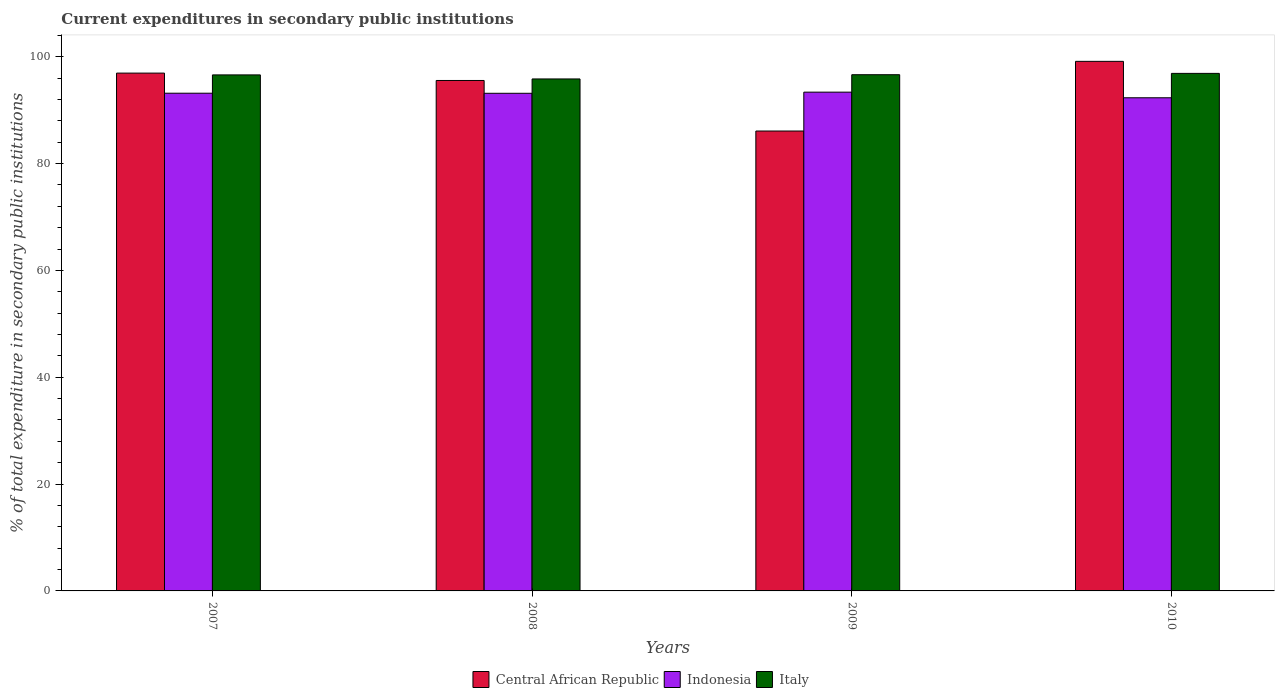How many different coloured bars are there?
Your response must be concise. 3. Are the number of bars per tick equal to the number of legend labels?
Offer a very short reply. Yes. How many bars are there on the 1st tick from the left?
Your answer should be compact. 3. How many bars are there on the 1st tick from the right?
Offer a terse response. 3. In how many cases, is the number of bars for a given year not equal to the number of legend labels?
Give a very brief answer. 0. What is the current expenditures in secondary public institutions in Central African Republic in 2009?
Your response must be concise. 86.08. Across all years, what is the maximum current expenditures in secondary public institutions in Italy?
Your answer should be very brief. 96.87. Across all years, what is the minimum current expenditures in secondary public institutions in Italy?
Make the answer very short. 95.83. In which year was the current expenditures in secondary public institutions in Indonesia maximum?
Your response must be concise. 2009. In which year was the current expenditures in secondary public institutions in Central African Republic minimum?
Your response must be concise. 2009. What is the total current expenditures in secondary public institutions in Central African Republic in the graph?
Offer a very short reply. 377.68. What is the difference between the current expenditures in secondary public institutions in Central African Republic in 2007 and that in 2009?
Ensure brevity in your answer.  10.84. What is the difference between the current expenditures in secondary public institutions in Indonesia in 2008 and the current expenditures in secondary public institutions in Central African Republic in 2010?
Your answer should be very brief. -5.98. What is the average current expenditures in secondary public institutions in Central African Republic per year?
Make the answer very short. 94.42. In the year 2010, what is the difference between the current expenditures in secondary public institutions in Central African Republic and current expenditures in secondary public institutions in Italy?
Keep it short and to the point. 2.25. In how many years, is the current expenditures in secondary public institutions in Central African Republic greater than 52 %?
Give a very brief answer. 4. What is the ratio of the current expenditures in secondary public institutions in Indonesia in 2008 to that in 2010?
Ensure brevity in your answer.  1.01. What is the difference between the highest and the second highest current expenditures in secondary public institutions in Indonesia?
Ensure brevity in your answer.  0.2. What is the difference between the highest and the lowest current expenditures in secondary public institutions in Italy?
Keep it short and to the point. 1.04. What does the 1st bar from the left in 2009 represents?
Give a very brief answer. Central African Republic. How many bars are there?
Offer a very short reply. 12. Are the values on the major ticks of Y-axis written in scientific E-notation?
Your answer should be very brief. No. Does the graph contain any zero values?
Keep it short and to the point. No. Where does the legend appear in the graph?
Offer a very short reply. Bottom center. How many legend labels are there?
Ensure brevity in your answer.  3. How are the legend labels stacked?
Provide a short and direct response. Horizontal. What is the title of the graph?
Ensure brevity in your answer.  Current expenditures in secondary public institutions. What is the label or title of the X-axis?
Make the answer very short. Years. What is the label or title of the Y-axis?
Offer a very short reply. % of total expenditure in secondary public institutions. What is the % of total expenditure in secondary public institutions in Central African Republic in 2007?
Ensure brevity in your answer.  96.92. What is the % of total expenditure in secondary public institutions of Indonesia in 2007?
Ensure brevity in your answer.  93.16. What is the % of total expenditure in secondary public institutions in Italy in 2007?
Offer a terse response. 96.59. What is the % of total expenditure in secondary public institutions of Central African Republic in 2008?
Provide a succinct answer. 95.54. What is the % of total expenditure in secondary public institutions in Indonesia in 2008?
Make the answer very short. 93.15. What is the % of total expenditure in secondary public institutions in Italy in 2008?
Offer a terse response. 95.83. What is the % of total expenditure in secondary public institutions in Central African Republic in 2009?
Ensure brevity in your answer.  86.08. What is the % of total expenditure in secondary public institutions of Indonesia in 2009?
Provide a short and direct response. 93.36. What is the % of total expenditure in secondary public institutions of Italy in 2009?
Provide a short and direct response. 96.62. What is the % of total expenditure in secondary public institutions of Central African Republic in 2010?
Your answer should be very brief. 99.12. What is the % of total expenditure in secondary public institutions of Indonesia in 2010?
Give a very brief answer. 92.31. What is the % of total expenditure in secondary public institutions in Italy in 2010?
Provide a short and direct response. 96.87. Across all years, what is the maximum % of total expenditure in secondary public institutions of Central African Republic?
Make the answer very short. 99.12. Across all years, what is the maximum % of total expenditure in secondary public institutions in Indonesia?
Offer a terse response. 93.36. Across all years, what is the maximum % of total expenditure in secondary public institutions in Italy?
Your answer should be very brief. 96.87. Across all years, what is the minimum % of total expenditure in secondary public institutions of Central African Republic?
Provide a short and direct response. 86.08. Across all years, what is the minimum % of total expenditure in secondary public institutions in Indonesia?
Offer a terse response. 92.31. Across all years, what is the minimum % of total expenditure in secondary public institutions of Italy?
Provide a short and direct response. 95.83. What is the total % of total expenditure in secondary public institutions in Central African Republic in the graph?
Provide a short and direct response. 377.68. What is the total % of total expenditure in secondary public institutions in Indonesia in the graph?
Provide a succinct answer. 371.97. What is the total % of total expenditure in secondary public institutions in Italy in the graph?
Offer a very short reply. 385.92. What is the difference between the % of total expenditure in secondary public institutions in Central African Republic in 2007 and that in 2008?
Your response must be concise. 1.38. What is the difference between the % of total expenditure in secondary public institutions in Indonesia in 2007 and that in 2008?
Your answer should be compact. 0.02. What is the difference between the % of total expenditure in secondary public institutions in Italy in 2007 and that in 2008?
Your answer should be very brief. 0.76. What is the difference between the % of total expenditure in secondary public institutions in Central African Republic in 2007 and that in 2009?
Offer a terse response. 10.84. What is the difference between the % of total expenditure in secondary public institutions of Indonesia in 2007 and that in 2009?
Provide a short and direct response. -0.2. What is the difference between the % of total expenditure in secondary public institutions of Italy in 2007 and that in 2009?
Provide a short and direct response. -0.03. What is the difference between the % of total expenditure in secondary public institutions of Indonesia in 2007 and that in 2010?
Give a very brief answer. 0.85. What is the difference between the % of total expenditure in secondary public institutions in Italy in 2007 and that in 2010?
Your answer should be very brief. -0.28. What is the difference between the % of total expenditure in secondary public institutions in Central African Republic in 2008 and that in 2009?
Your answer should be compact. 9.46. What is the difference between the % of total expenditure in secondary public institutions of Indonesia in 2008 and that in 2009?
Offer a terse response. -0.21. What is the difference between the % of total expenditure in secondary public institutions of Italy in 2008 and that in 2009?
Your answer should be compact. -0.79. What is the difference between the % of total expenditure in secondary public institutions of Central African Republic in 2008 and that in 2010?
Offer a very short reply. -3.58. What is the difference between the % of total expenditure in secondary public institutions in Indonesia in 2008 and that in 2010?
Offer a very short reply. 0.84. What is the difference between the % of total expenditure in secondary public institutions in Italy in 2008 and that in 2010?
Keep it short and to the point. -1.04. What is the difference between the % of total expenditure in secondary public institutions of Central African Republic in 2009 and that in 2010?
Make the answer very short. -13.04. What is the difference between the % of total expenditure in secondary public institutions of Indonesia in 2009 and that in 2010?
Your response must be concise. 1.05. What is the difference between the % of total expenditure in secondary public institutions in Italy in 2009 and that in 2010?
Offer a very short reply. -0.25. What is the difference between the % of total expenditure in secondary public institutions of Central African Republic in 2007 and the % of total expenditure in secondary public institutions of Indonesia in 2008?
Ensure brevity in your answer.  3.78. What is the difference between the % of total expenditure in secondary public institutions in Central African Republic in 2007 and the % of total expenditure in secondary public institutions in Italy in 2008?
Keep it short and to the point. 1.09. What is the difference between the % of total expenditure in secondary public institutions in Indonesia in 2007 and the % of total expenditure in secondary public institutions in Italy in 2008?
Give a very brief answer. -2.67. What is the difference between the % of total expenditure in secondary public institutions in Central African Republic in 2007 and the % of total expenditure in secondary public institutions in Indonesia in 2009?
Offer a very short reply. 3.56. What is the difference between the % of total expenditure in secondary public institutions of Central African Republic in 2007 and the % of total expenditure in secondary public institutions of Italy in 2009?
Ensure brevity in your answer.  0.3. What is the difference between the % of total expenditure in secondary public institutions in Indonesia in 2007 and the % of total expenditure in secondary public institutions in Italy in 2009?
Offer a terse response. -3.46. What is the difference between the % of total expenditure in secondary public institutions of Central African Republic in 2007 and the % of total expenditure in secondary public institutions of Indonesia in 2010?
Give a very brief answer. 4.62. What is the difference between the % of total expenditure in secondary public institutions of Central African Republic in 2007 and the % of total expenditure in secondary public institutions of Italy in 2010?
Provide a succinct answer. 0.05. What is the difference between the % of total expenditure in secondary public institutions in Indonesia in 2007 and the % of total expenditure in secondary public institutions in Italy in 2010?
Make the answer very short. -3.71. What is the difference between the % of total expenditure in secondary public institutions of Central African Republic in 2008 and the % of total expenditure in secondary public institutions of Indonesia in 2009?
Keep it short and to the point. 2.19. What is the difference between the % of total expenditure in secondary public institutions in Central African Republic in 2008 and the % of total expenditure in secondary public institutions in Italy in 2009?
Provide a succinct answer. -1.08. What is the difference between the % of total expenditure in secondary public institutions of Indonesia in 2008 and the % of total expenditure in secondary public institutions of Italy in 2009?
Your answer should be very brief. -3.48. What is the difference between the % of total expenditure in secondary public institutions in Central African Republic in 2008 and the % of total expenditure in secondary public institutions in Indonesia in 2010?
Keep it short and to the point. 3.24. What is the difference between the % of total expenditure in secondary public institutions in Central African Republic in 2008 and the % of total expenditure in secondary public institutions in Italy in 2010?
Offer a terse response. -1.33. What is the difference between the % of total expenditure in secondary public institutions of Indonesia in 2008 and the % of total expenditure in secondary public institutions of Italy in 2010?
Provide a succinct answer. -3.73. What is the difference between the % of total expenditure in secondary public institutions of Central African Republic in 2009 and the % of total expenditure in secondary public institutions of Indonesia in 2010?
Provide a short and direct response. -6.22. What is the difference between the % of total expenditure in secondary public institutions in Central African Republic in 2009 and the % of total expenditure in secondary public institutions in Italy in 2010?
Keep it short and to the point. -10.79. What is the difference between the % of total expenditure in secondary public institutions in Indonesia in 2009 and the % of total expenditure in secondary public institutions in Italy in 2010?
Your answer should be compact. -3.51. What is the average % of total expenditure in secondary public institutions in Central African Republic per year?
Provide a succinct answer. 94.42. What is the average % of total expenditure in secondary public institutions of Indonesia per year?
Make the answer very short. 92.99. What is the average % of total expenditure in secondary public institutions of Italy per year?
Your response must be concise. 96.48. In the year 2007, what is the difference between the % of total expenditure in secondary public institutions of Central African Republic and % of total expenditure in secondary public institutions of Indonesia?
Provide a short and direct response. 3.76. In the year 2007, what is the difference between the % of total expenditure in secondary public institutions of Central African Republic and % of total expenditure in secondary public institutions of Italy?
Your answer should be compact. 0.33. In the year 2007, what is the difference between the % of total expenditure in secondary public institutions in Indonesia and % of total expenditure in secondary public institutions in Italy?
Ensure brevity in your answer.  -3.43. In the year 2008, what is the difference between the % of total expenditure in secondary public institutions in Central African Republic and % of total expenditure in secondary public institutions in Indonesia?
Make the answer very short. 2.4. In the year 2008, what is the difference between the % of total expenditure in secondary public institutions in Central African Republic and % of total expenditure in secondary public institutions in Italy?
Provide a short and direct response. -0.29. In the year 2008, what is the difference between the % of total expenditure in secondary public institutions of Indonesia and % of total expenditure in secondary public institutions of Italy?
Offer a very short reply. -2.69. In the year 2009, what is the difference between the % of total expenditure in secondary public institutions of Central African Republic and % of total expenditure in secondary public institutions of Indonesia?
Your answer should be compact. -7.28. In the year 2009, what is the difference between the % of total expenditure in secondary public institutions of Central African Republic and % of total expenditure in secondary public institutions of Italy?
Keep it short and to the point. -10.54. In the year 2009, what is the difference between the % of total expenditure in secondary public institutions in Indonesia and % of total expenditure in secondary public institutions in Italy?
Your response must be concise. -3.26. In the year 2010, what is the difference between the % of total expenditure in secondary public institutions in Central African Republic and % of total expenditure in secondary public institutions in Indonesia?
Keep it short and to the point. 6.82. In the year 2010, what is the difference between the % of total expenditure in secondary public institutions of Central African Republic and % of total expenditure in secondary public institutions of Italy?
Make the answer very short. 2.25. In the year 2010, what is the difference between the % of total expenditure in secondary public institutions in Indonesia and % of total expenditure in secondary public institutions in Italy?
Make the answer very short. -4.57. What is the ratio of the % of total expenditure in secondary public institutions of Central African Republic in 2007 to that in 2008?
Ensure brevity in your answer.  1.01. What is the ratio of the % of total expenditure in secondary public institutions of Indonesia in 2007 to that in 2008?
Ensure brevity in your answer.  1. What is the ratio of the % of total expenditure in secondary public institutions of Italy in 2007 to that in 2008?
Keep it short and to the point. 1.01. What is the ratio of the % of total expenditure in secondary public institutions in Central African Republic in 2007 to that in 2009?
Keep it short and to the point. 1.13. What is the ratio of the % of total expenditure in secondary public institutions in Central African Republic in 2007 to that in 2010?
Offer a very short reply. 0.98. What is the ratio of the % of total expenditure in secondary public institutions of Indonesia in 2007 to that in 2010?
Provide a succinct answer. 1.01. What is the ratio of the % of total expenditure in secondary public institutions of Central African Republic in 2008 to that in 2009?
Offer a very short reply. 1.11. What is the ratio of the % of total expenditure in secondary public institutions in Indonesia in 2008 to that in 2009?
Offer a terse response. 1. What is the ratio of the % of total expenditure in secondary public institutions of Italy in 2008 to that in 2009?
Keep it short and to the point. 0.99. What is the ratio of the % of total expenditure in secondary public institutions in Central African Republic in 2008 to that in 2010?
Your answer should be very brief. 0.96. What is the ratio of the % of total expenditure in secondary public institutions in Indonesia in 2008 to that in 2010?
Give a very brief answer. 1.01. What is the ratio of the % of total expenditure in secondary public institutions in Italy in 2008 to that in 2010?
Ensure brevity in your answer.  0.99. What is the ratio of the % of total expenditure in secondary public institutions in Central African Republic in 2009 to that in 2010?
Provide a short and direct response. 0.87. What is the ratio of the % of total expenditure in secondary public institutions of Indonesia in 2009 to that in 2010?
Your answer should be compact. 1.01. What is the difference between the highest and the second highest % of total expenditure in secondary public institutions in Indonesia?
Make the answer very short. 0.2. What is the difference between the highest and the second highest % of total expenditure in secondary public institutions in Italy?
Ensure brevity in your answer.  0.25. What is the difference between the highest and the lowest % of total expenditure in secondary public institutions of Central African Republic?
Your answer should be very brief. 13.04. What is the difference between the highest and the lowest % of total expenditure in secondary public institutions in Indonesia?
Give a very brief answer. 1.05. What is the difference between the highest and the lowest % of total expenditure in secondary public institutions of Italy?
Your answer should be very brief. 1.04. 